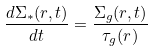Convert formula to latex. <formula><loc_0><loc_0><loc_500><loc_500>\frac { d \Sigma _ { * } ( r , t ) } { d t } = \frac { \Sigma _ { g } ( r , t ) } { \tau _ { g } ( r ) }</formula> 